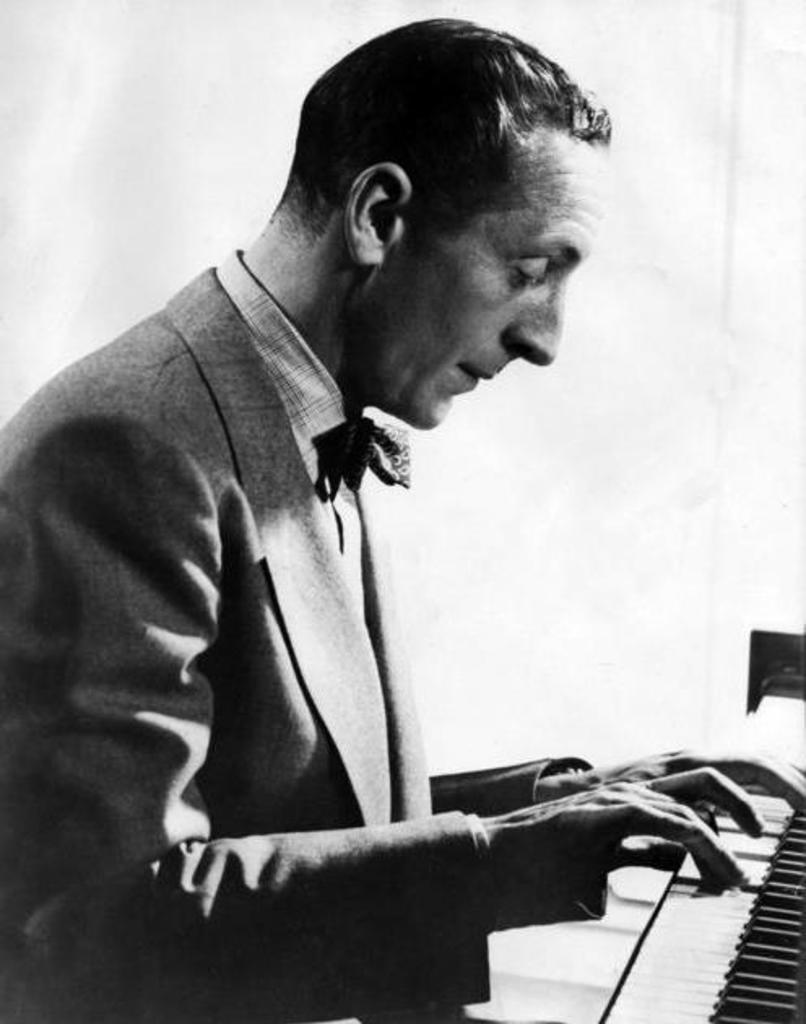What is the main subject of subject of the image? The main subject of the image is a man. What is the man doing in the image? The man is playing the piano in the image. How many boats are visible in the painting in the image? There is no painting or boats present in the image; it features a man playing the piano. What type of canvas is the man using to create his artwork in the image? There is no canvas or artwork being created in the image; the man is playing the piano. 